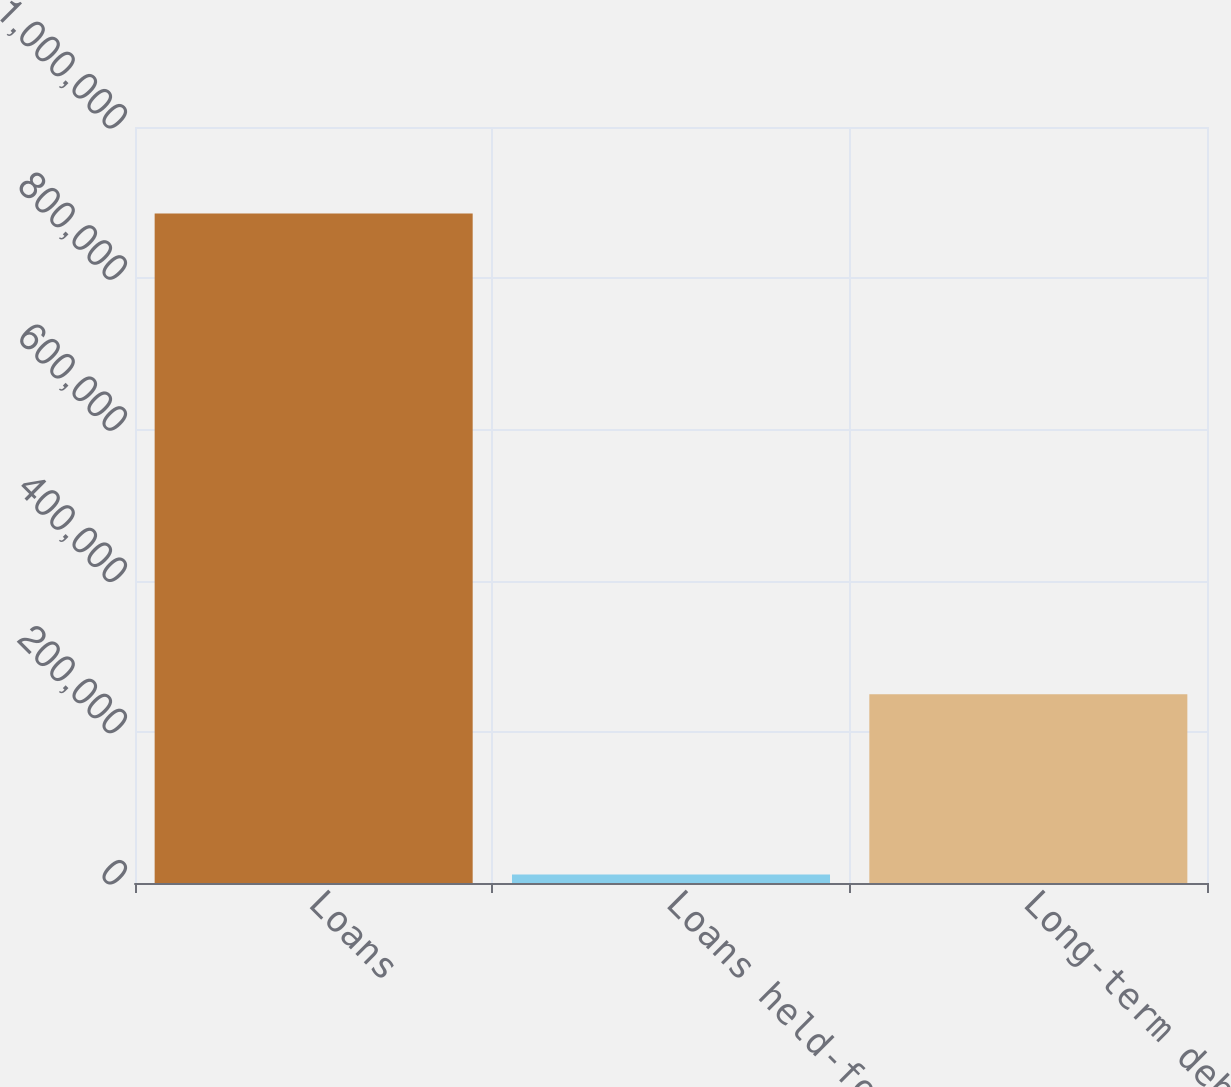Convert chart to OTSL. <chart><loc_0><loc_0><loc_500><loc_500><bar_chart><fcel>Loans<fcel>Loans held-for-sale<fcel>Long-term debt<nl><fcel>885724<fcel>11362<fcel>249674<nl></chart> 